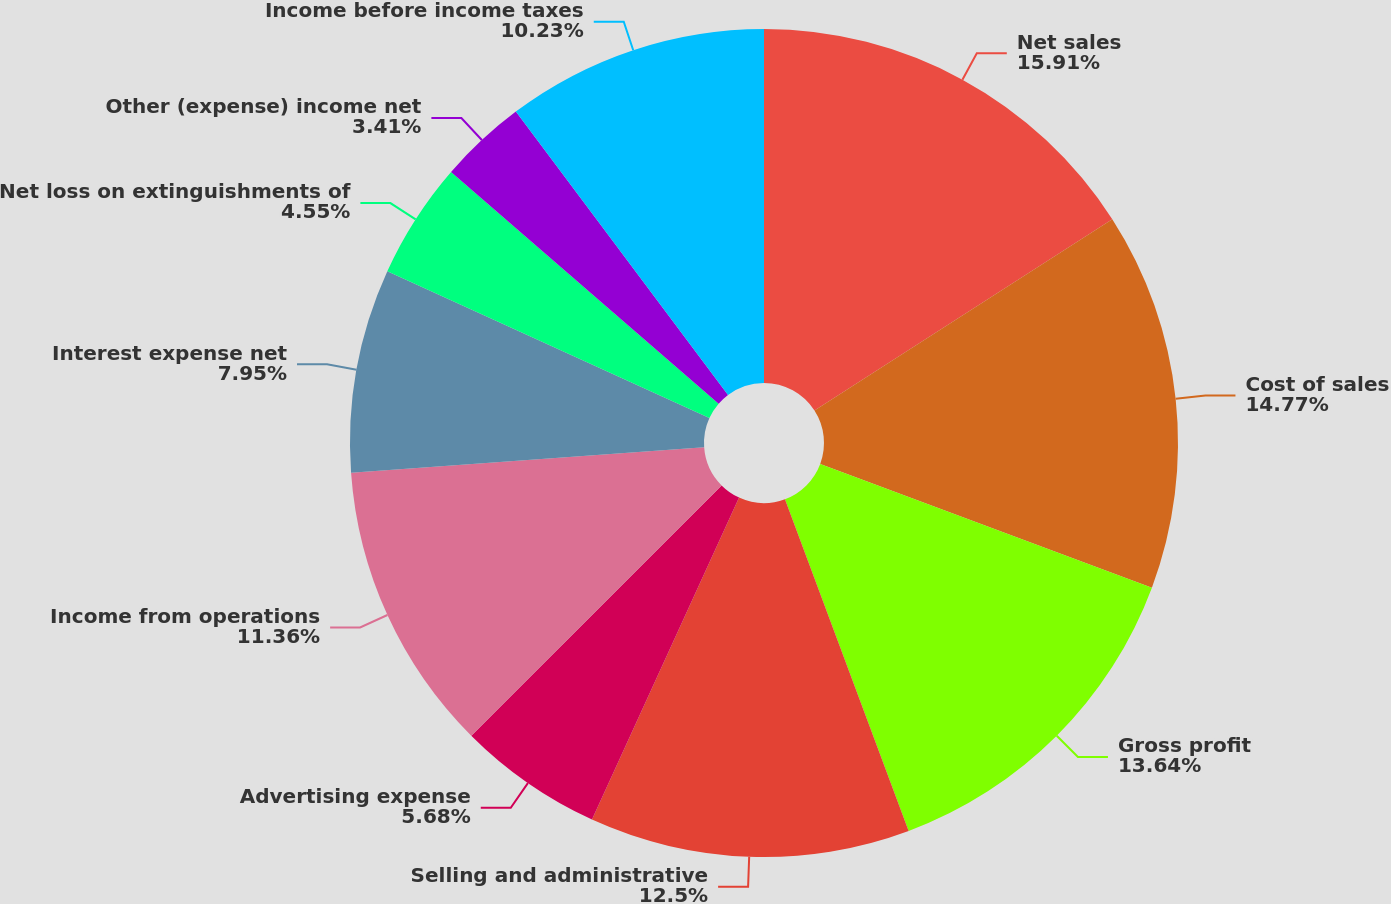<chart> <loc_0><loc_0><loc_500><loc_500><pie_chart><fcel>Net sales<fcel>Cost of sales<fcel>Gross profit<fcel>Selling and administrative<fcel>Advertising expense<fcel>Income from operations<fcel>Interest expense net<fcel>Net loss on extinguishments of<fcel>Other (expense) income net<fcel>Income before income taxes<nl><fcel>15.91%<fcel>14.77%<fcel>13.64%<fcel>12.5%<fcel>5.68%<fcel>11.36%<fcel>7.95%<fcel>4.55%<fcel>3.41%<fcel>10.23%<nl></chart> 